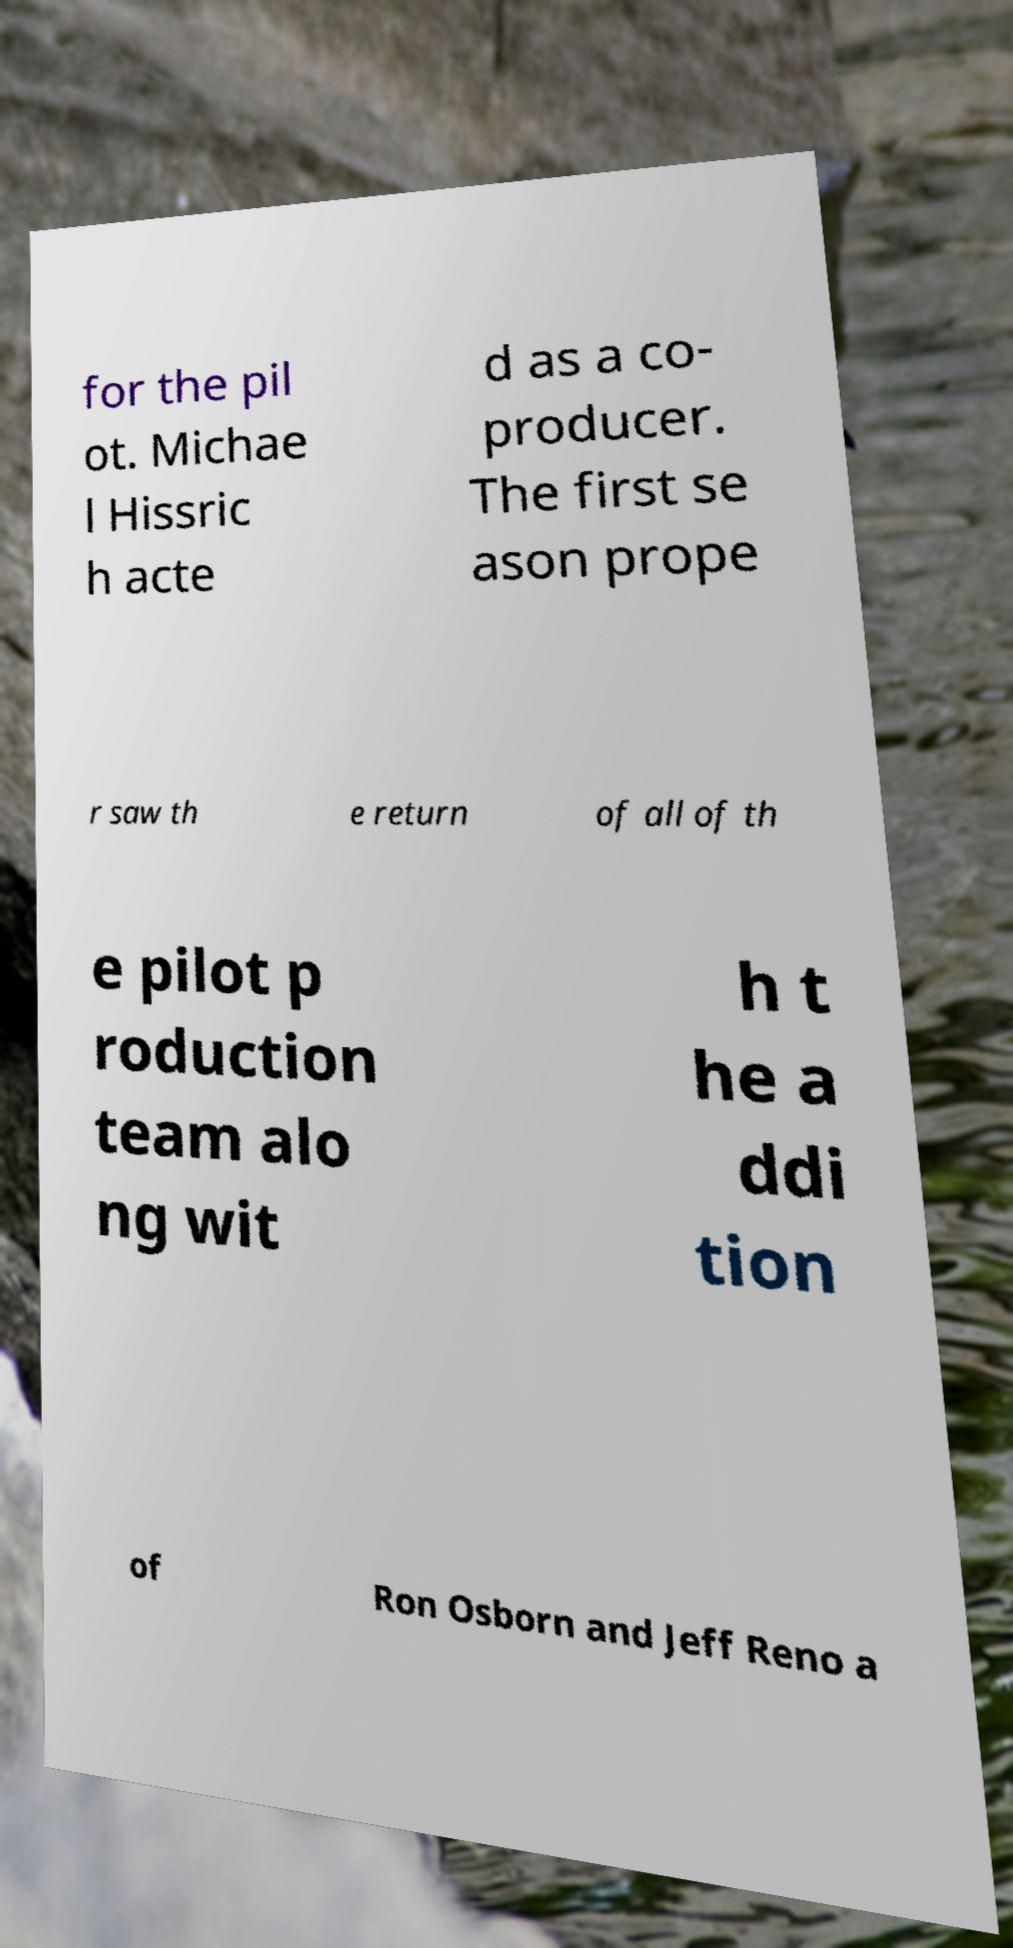Can you accurately transcribe the text from the provided image for me? for the pil ot. Michae l Hissric h acte d as a co- producer. The first se ason prope r saw th e return of all of th e pilot p roduction team alo ng wit h t he a ddi tion of Ron Osborn and Jeff Reno a 